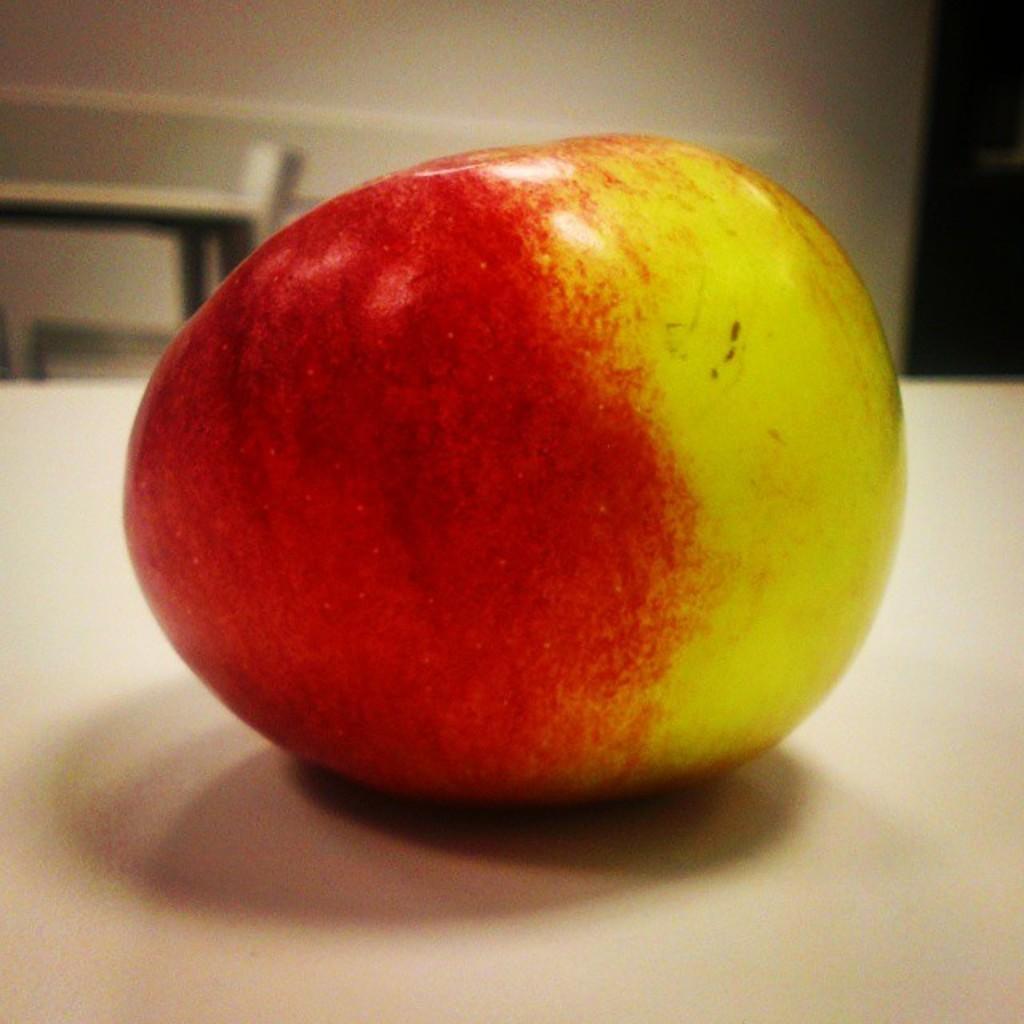How would you summarize this image in a sentence or two? On this white surface we can see an apple. Background it is blur. 